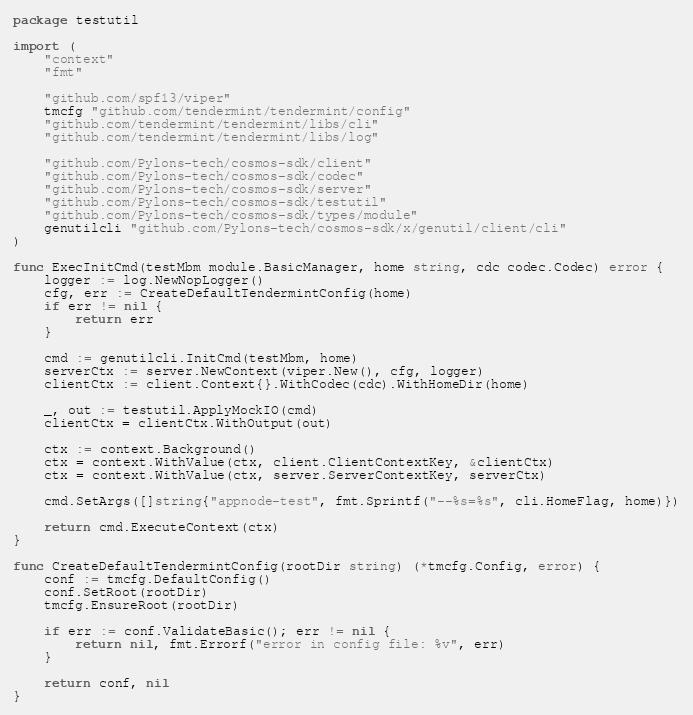Convert code to text. <code><loc_0><loc_0><loc_500><loc_500><_Go_>package testutil

import (
	"context"
	"fmt"

	"github.com/spf13/viper"
	tmcfg "github.com/tendermint/tendermint/config"
	"github.com/tendermint/tendermint/libs/cli"
	"github.com/tendermint/tendermint/libs/log"

	"github.com/Pylons-tech/cosmos-sdk/client"
	"github.com/Pylons-tech/cosmos-sdk/codec"
	"github.com/Pylons-tech/cosmos-sdk/server"
	"github.com/Pylons-tech/cosmos-sdk/testutil"
	"github.com/Pylons-tech/cosmos-sdk/types/module"
	genutilcli "github.com/Pylons-tech/cosmos-sdk/x/genutil/client/cli"
)

func ExecInitCmd(testMbm module.BasicManager, home string, cdc codec.Codec) error {
	logger := log.NewNopLogger()
	cfg, err := CreateDefaultTendermintConfig(home)
	if err != nil {
		return err
	}

	cmd := genutilcli.InitCmd(testMbm, home)
	serverCtx := server.NewContext(viper.New(), cfg, logger)
	clientCtx := client.Context{}.WithCodec(cdc).WithHomeDir(home)

	_, out := testutil.ApplyMockIO(cmd)
	clientCtx = clientCtx.WithOutput(out)

	ctx := context.Background()
	ctx = context.WithValue(ctx, client.ClientContextKey, &clientCtx)
	ctx = context.WithValue(ctx, server.ServerContextKey, serverCtx)

	cmd.SetArgs([]string{"appnode-test", fmt.Sprintf("--%s=%s", cli.HomeFlag, home)})

	return cmd.ExecuteContext(ctx)
}

func CreateDefaultTendermintConfig(rootDir string) (*tmcfg.Config, error) {
	conf := tmcfg.DefaultConfig()
	conf.SetRoot(rootDir)
	tmcfg.EnsureRoot(rootDir)

	if err := conf.ValidateBasic(); err != nil {
		return nil, fmt.Errorf("error in config file: %v", err)
	}

	return conf, nil
}
</code> 